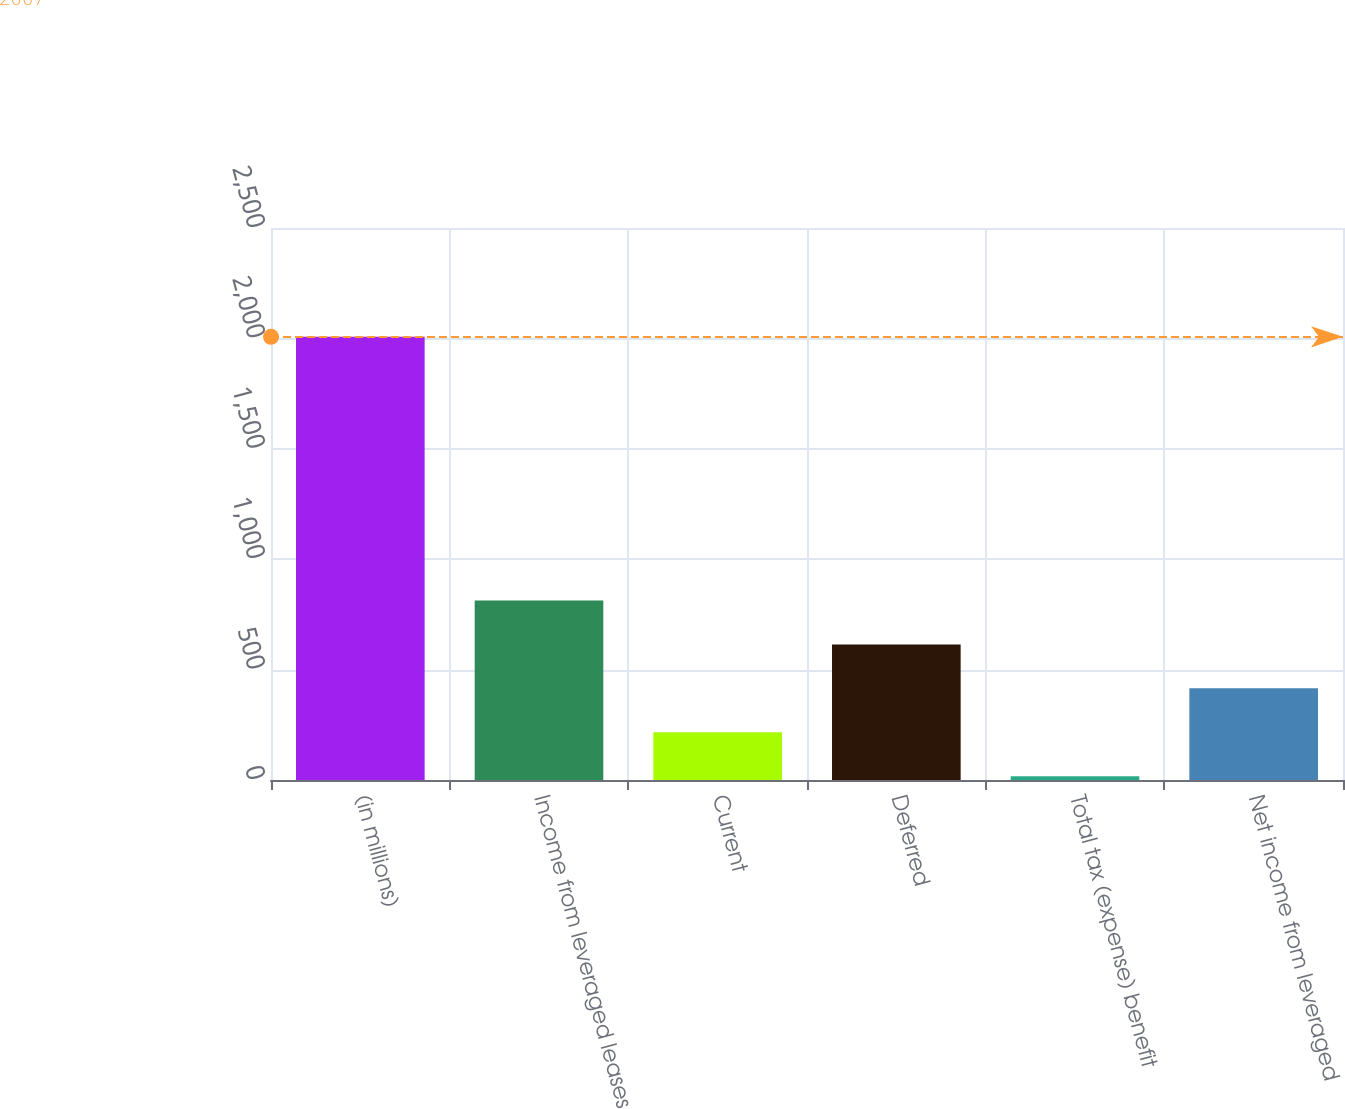<chart> <loc_0><loc_0><loc_500><loc_500><bar_chart><fcel>(in millions)<fcel>Income from leveraged leases<fcel>Current<fcel>Deferred<fcel>Total tax (expense) benefit<fcel>Net income from leveraged<nl><fcel>2007<fcel>813<fcel>216<fcel>614<fcel>17<fcel>415<nl></chart> 